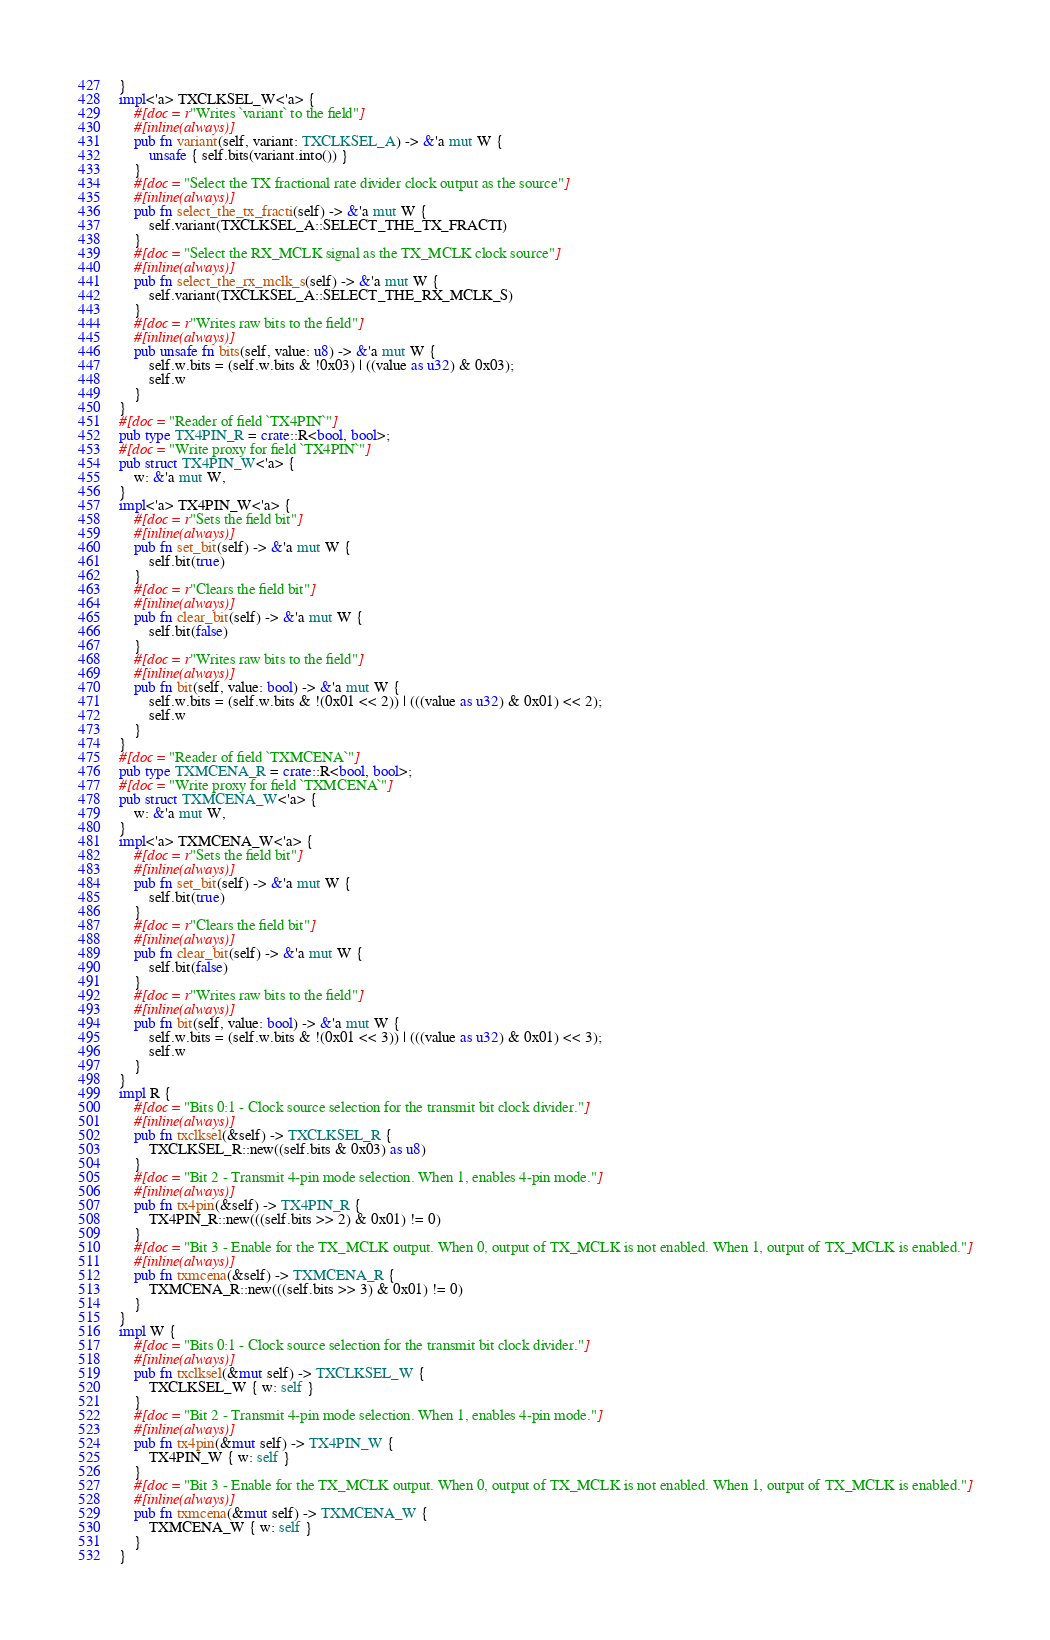<code> <loc_0><loc_0><loc_500><loc_500><_Rust_>}
impl<'a> TXCLKSEL_W<'a> {
    #[doc = r"Writes `variant` to the field"]
    #[inline(always)]
    pub fn variant(self, variant: TXCLKSEL_A) -> &'a mut W {
        unsafe { self.bits(variant.into()) }
    }
    #[doc = "Select the TX fractional rate divider clock output as the source"]
    #[inline(always)]
    pub fn select_the_tx_fracti(self) -> &'a mut W {
        self.variant(TXCLKSEL_A::SELECT_THE_TX_FRACTI)
    }
    #[doc = "Select the RX_MCLK signal as the TX_MCLK clock source"]
    #[inline(always)]
    pub fn select_the_rx_mclk_s(self) -> &'a mut W {
        self.variant(TXCLKSEL_A::SELECT_THE_RX_MCLK_S)
    }
    #[doc = r"Writes raw bits to the field"]
    #[inline(always)]
    pub unsafe fn bits(self, value: u8) -> &'a mut W {
        self.w.bits = (self.w.bits & !0x03) | ((value as u32) & 0x03);
        self.w
    }
}
#[doc = "Reader of field `TX4PIN`"]
pub type TX4PIN_R = crate::R<bool, bool>;
#[doc = "Write proxy for field `TX4PIN`"]
pub struct TX4PIN_W<'a> {
    w: &'a mut W,
}
impl<'a> TX4PIN_W<'a> {
    #[doc = r"Sets the field bit"]
    #[inline(always)]
    pub fn set_bit(self) -> &'a mut W {
        self.bit(true)
    }
    #[doc = r"Clears the field bit"]
    #[inline(always)]
    pub fn clear_bit(self) -> &'a mut W {
        self.bit(false)
    }
    #[doc = r"Writes raw bits to the field"]
    #[inline(always)]
    pub fn bit(self, value: bool) -> &'a mut W {
        self.w.bits = (self.w.bits & !(0x01 << 2)) | (((value as u32) & 0x01) << 2);
        self.w
    }
}
#[doc = "Reader of field `TXMCENA`"]
pub type TXMCENA_R = crate::R<bool, bool>;
#[doc = "Write proxy for field `TXMCENA`"]
pub struct TXMCENA_W<'a> {
    w: &'a mut W,
}
impl<'a> TXMCENA_W<'a> {
    #[doc = r"Sets the field bit"]
    #[inline(always)]
    pub fn set_bit(self) -> &'a mut W {
        self.bit(true)
    }
    #[doc = r"Clears the field bit"]
    #[inline(always)]
    pub fn clear_bit(self) -> &'a mut W {
        self.bit(false)
    }
    #[doc = r"Writes raw bits to the field"]
    #[inline(always)]
    pub fn bit(self, value: bool) -> &'a mut W {
        self.w.bits = (self.w.bits & !(0x01 << 3)) | (((value as u32) & 0x01) << 3);
        self.w
    }
}
impl R {
    #[doc = "Bits 0:1 - Clock source selection for the transmit bit clock divider."]
    #[inline(always)]
    pub fn txclksel(&self) -> TXCLKSEL_R {
        TXCLKSEL_R::new((self.bits & 0x03) as u8)
    }
    #[doc = "Bit 2 - Transmit 4-pin mode selection. When 1, enables 4-pin mode."]
    #[inline(always)]
    pub fn tx4pin(&self) -> TX4PIN_R {
        TX4PIN_R::new(((self.bits >> 2) & 0x01) != 0)
    }
    #[doc = "Bit 3 - Enable for the TX_MCLK output. When 0, output of TX_MCLK is not enabled. When 1, output of TX_MCLK is enabled."]
    #[inline(always)]
    pub fn txmcena(&self) -> TXMCENA_R {
        TXMCENA_R::new(((self.bits >> 3) & 0x01) != 0)
    }
}
impl W {
    #[doc = "Bits 0:1 - Clock source selection for the transmit bit clock divider."]
    #[inline(always)]
    pub fn txclksel(&mut self) -> TXCLKSEL_W {
        TXCLKSEL_W { w: self }
    }
    #[doc = "Bit 2 - Transmit 4-pin mode selection. When 1, enables 4-pin mode."]
    #[inline(always)]
    pub fn tx4pin(&mut self) -> TX4PIN_W {
        TX4PIN_W { w: self }
    }
    #[doc = "Bit 3 - Enable for the TX_MCLK output. When 0, output of TX_MCLK is not enabled. When 1, output of TX_MCLK is enabled."]
    #[inline(always)]
    pub fn txmcena(&mut self) -> TXMCENA_W {
        TXMCENA_W { w: self }
    }
}
</code> 